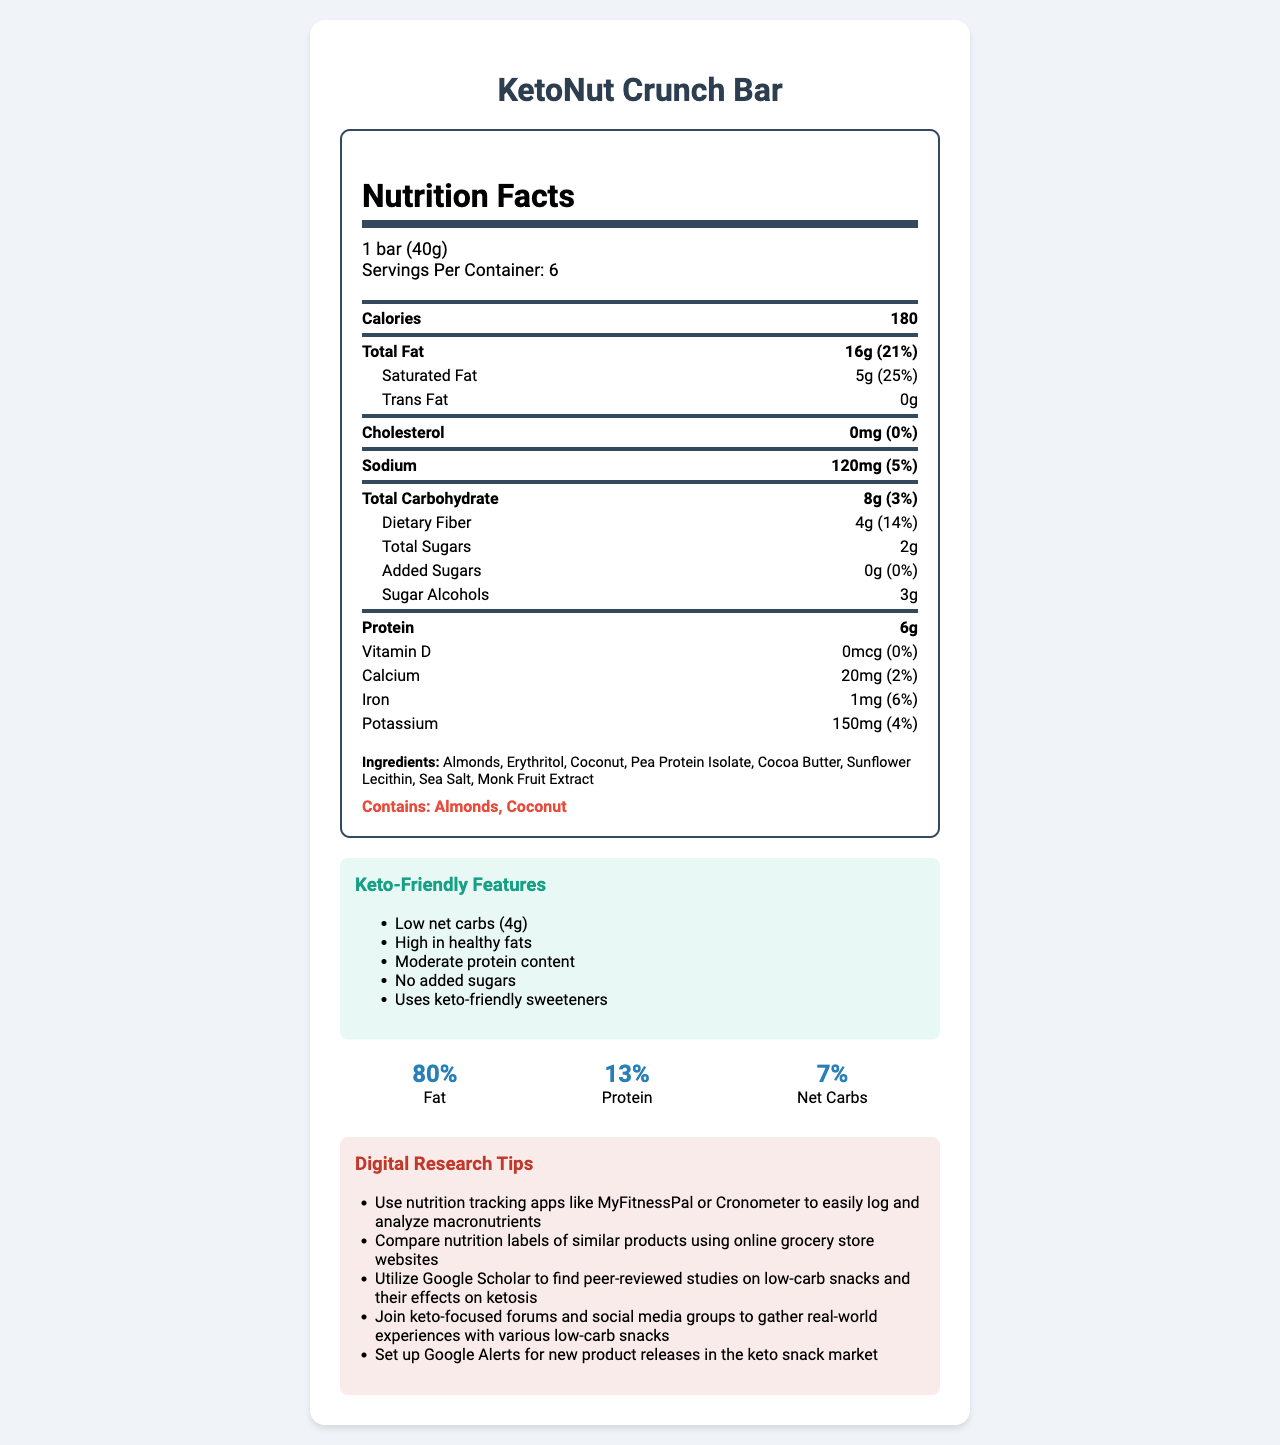How many calories are in one KetoNut Crunch Bar? The document clearly states that one KetoNut Crunch Bar contains 180 calories.
Answer: 180 What is the serving size of the KetoNut Crunch Bar? The document mentions that the serving size of the KetoNut Crunch Bar is 1 bar (40g).
Answer: 1 bar (40g) How many grams of total carbohydrates are in one KetoNut Crunch Bar? The total carbohydrate content is listed as 8g in the document.
Answer: 8g What percentage of the daily value of saturated fat does the KetoNut Crunch Bar contain? The document notes that the bar contains 5g of saturated fat, which is 25% of the daily value.
Answer: 25% What type of sweeteners are used in the KetoNut Crunch Bar? The ingredients section lists Erythritol and Monk Fruit Extract as the sweeteners used.
Answer: Erythritol, Monk Fruit Extract How many grams of protein does the KetoNut Crunch Bar have? The protein content of the bar is mentioned as 6g in the document.
Answer: 6g What are the allergens present in the KetoNut Crunch Bar? The document clearly states that the bar contains almonds and coconut, making these the allergens.
Answer: Almonds, Coconut What is the macronutrient breakdown for net carbs in the KetoNut Crunch Bar? The macronutrient breakdown chart in the document shows that net carbs make up 7% of the KetoNut Crunch Bar's content.
Answer: 7% Is there any cholesterol in the KetoNut Crunch Bar? The document states that the bar contains 0mg of cholesterol, which is 0% of the daily value.
Answer: No What is the main idea of the document? The main sections of the document cover the nutritional facts, ingredients, allergens, keto-friendly features, and digital research tips, all focused on the KetoNut Crunch Bar.
Answer: The document provides nutritional information about the KetoNut Crunch Bar, including its macronutrient breakdown, ingredients, allergens, and keto-friendly features. Which of the following keto-friendly features does the KetoNut Crunch Bar have? A. High Net Carbs B. High in Healthy Fats C. Contains Added Sugars The document lists "High in healthy fats" as one of the keto-friendly features, whereas it has low net carbs and no added sugars.
Answer: B. High in Healthy Fats What is the total amount of sugar alcohols in the KetoNut Crunch Bar? A. 1g B. 2g C. 3g D. 4g The document specifies that the KetoNut Crunch Bar has 3g of sugar alcohols.
Answer: C. 3g Does the KetoNut Crunch Bar contain any added sugars? The document clearly states that there are 0g of added sugars in the bar.
Answer: No Is it possible to determine the exact number of calories that come from fat in the KetoNut Crunch Bar? The document does not provide enough specific information about the caloric value of fat alone to determine the exact number of calories from fat.
Answer: Cannot be determined What digital research tip suggests a way to find peer-reviewed studies on low-carb snacks? This tip is listed under the digital research tips section in the document.
Answer: Utilize Google Scholar to find peer-reviewed studies on low-carb snacks and their effects on ketosis How many servings per container are there for the KetoNut Crunch Bar? The document states that there are 6 servings per container.
Answer: 6 